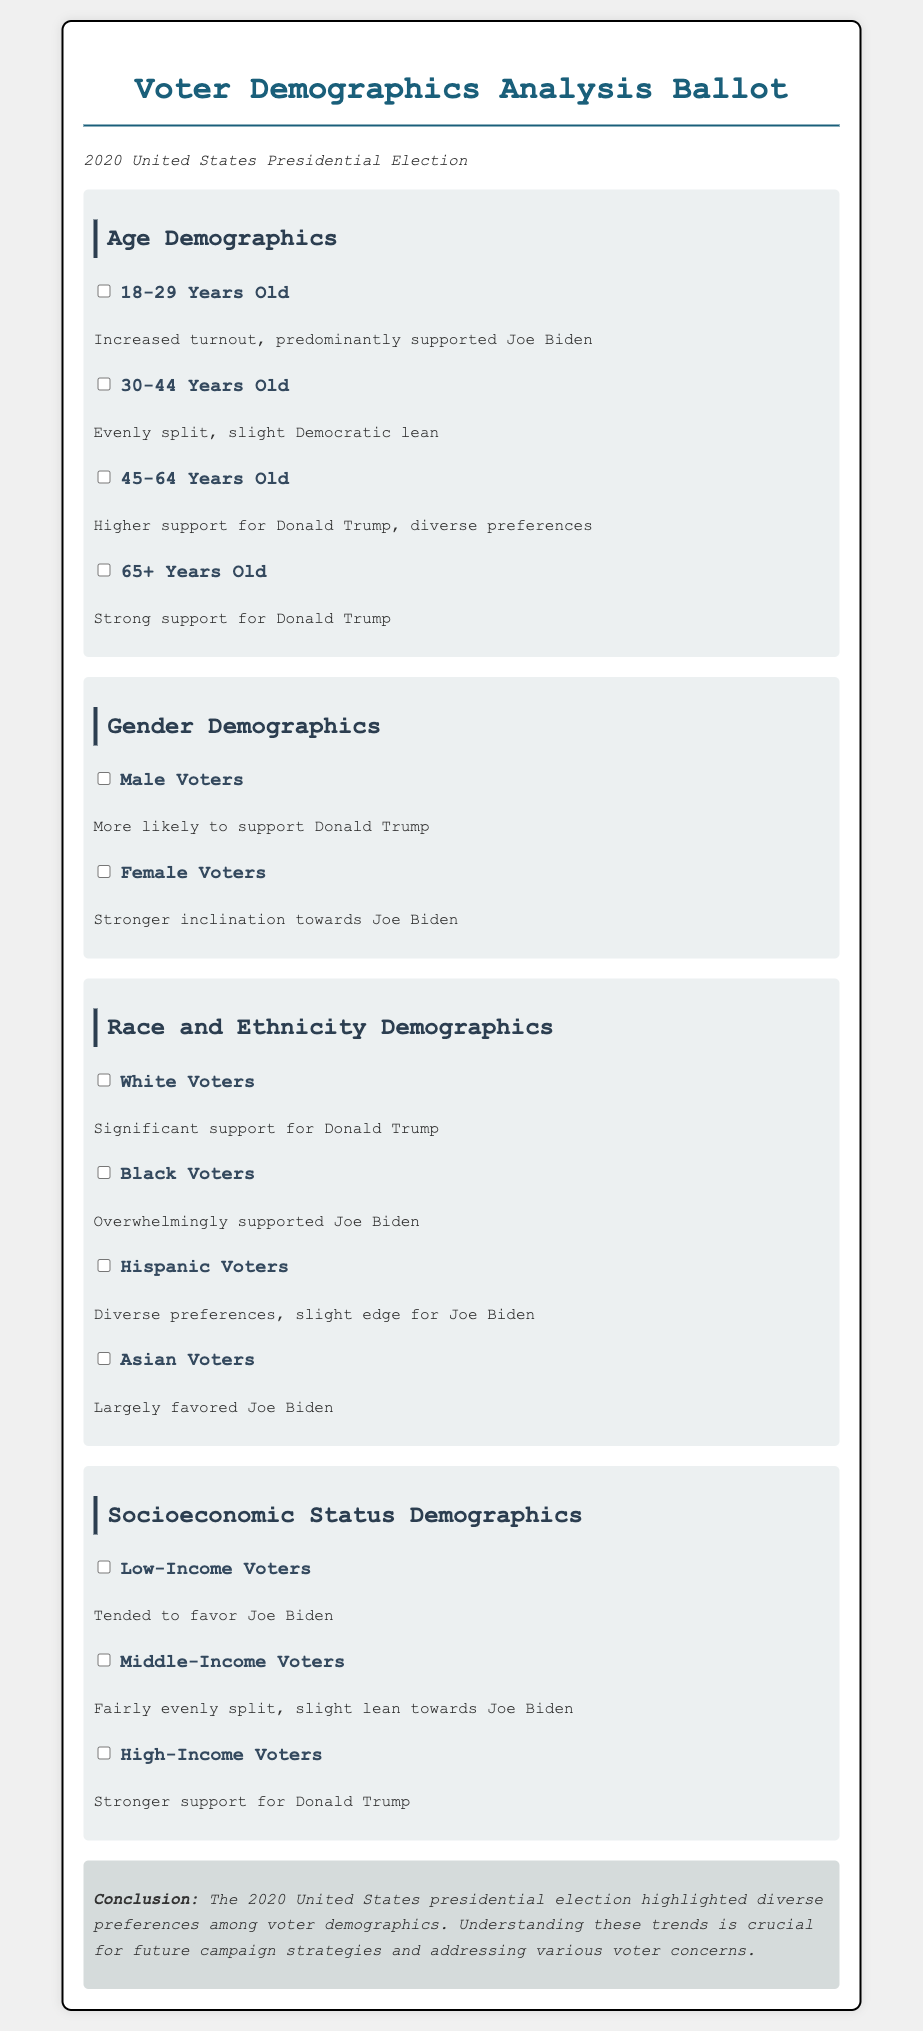What age group predominantly supported Joe Biden? The document states that the age group 18-29 years old had increased turnout and predominantly supported Joe Biden.
Answer: 18-29 Years Old Which gender was more likely to support Donald Trump? The document indicates that male voters were more likely to support Donald Trump.
Answer: Male Voters What was the support trend among Black voters? According to the document, Black voters overwhelmingly supported Joe Biden.
Answer: Overwhelmingly supported Joe Biden Which socioeconomic group tended to favor Joe Biden? The document mentions that low-income voters tended to favor Joe Biden.
Answer: Low-Income Voters What is the overall conclusion regarding voter demographics? The conclusion discusses that diverse preferences among voter demographics were highlighted in the election.
Answer: Diverse preferences among voter demographics Which age demographic showed stronger support for Donald Trump? The document states that voters aged 65 and older showed strong support for Donald Trump.
Answer: 65+ Years Old What race had significant support for Donald Trump? The document notes that White voters had significant support for Donald Trump.
Answer: White Voters What was the voting tendency of Asian voters? The document indicates that Asian voters largely favored Joe Biden.
Answer: Largely favored Joe Biden Which income group had a stronger support for Donald Trump? The document states that high-income voters showed stronger support for Donald Trump.
Answer: High-Income Voters 